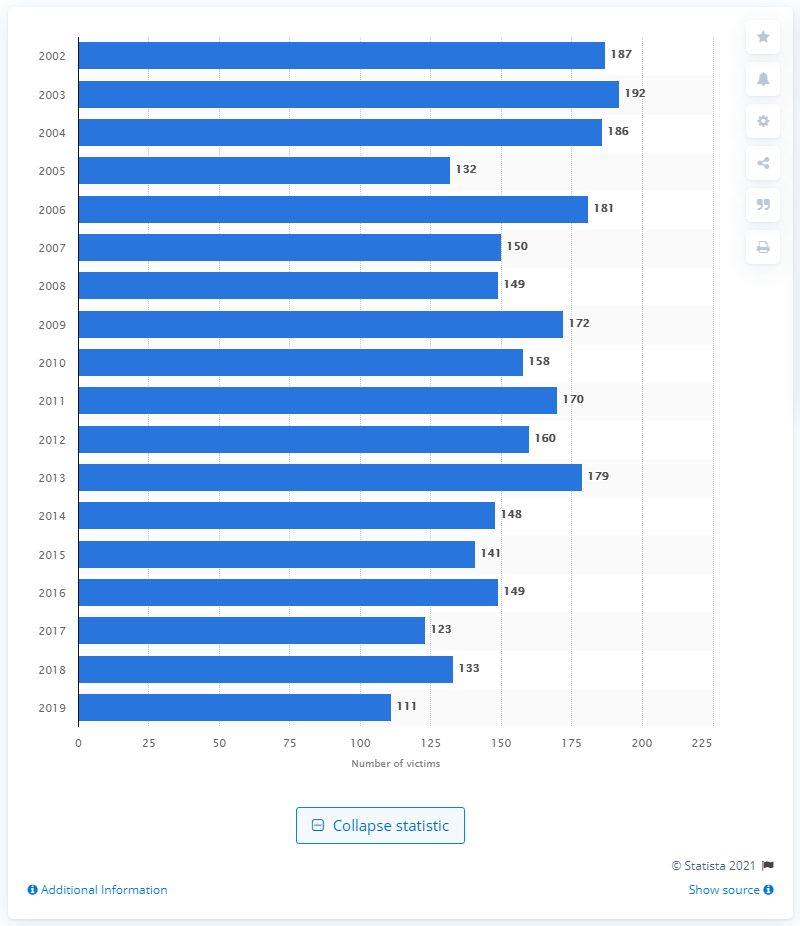List a handful of essential elements in this visual. In 2019, there were 111 women in Italy who were victims of homicide. 